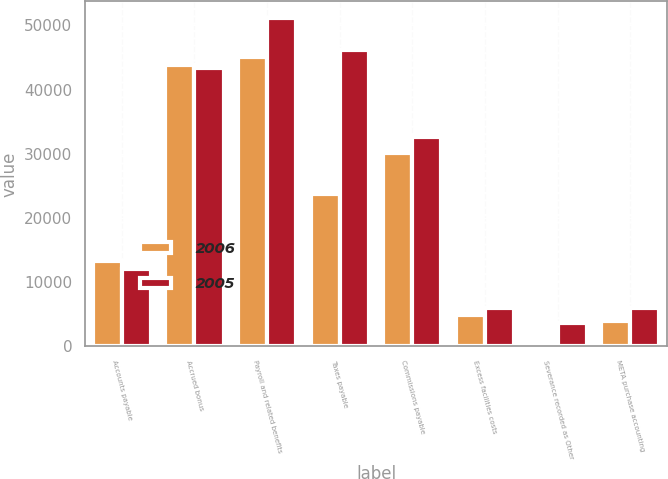Convert chart. <chart><loc_0><loc_0><loc_500><loc_500><stacked_bar_chart><ecel><fcel>Accounts payable<fcel>Accrued bonus<fcel>Payroll and related benefits<fcel>Taxes payable<fcel>Commissions payable<fcel>Excess facilities costs<fcel>Severance recorded as Other<fcel>META purchase accounting<nl><fcel>2006<fcel>13333<fcel>43901<fcel>45143<fcel>23795<fcel>30080<fcel>4896<fcel>681<fcel>3969<nl><fcel>2005<fcel>12071<fcel>43313<fcel>51191<fcel>46206<fcel>32540<fcel>5958<fcel>3591<fcel>5983<nl></chart> 